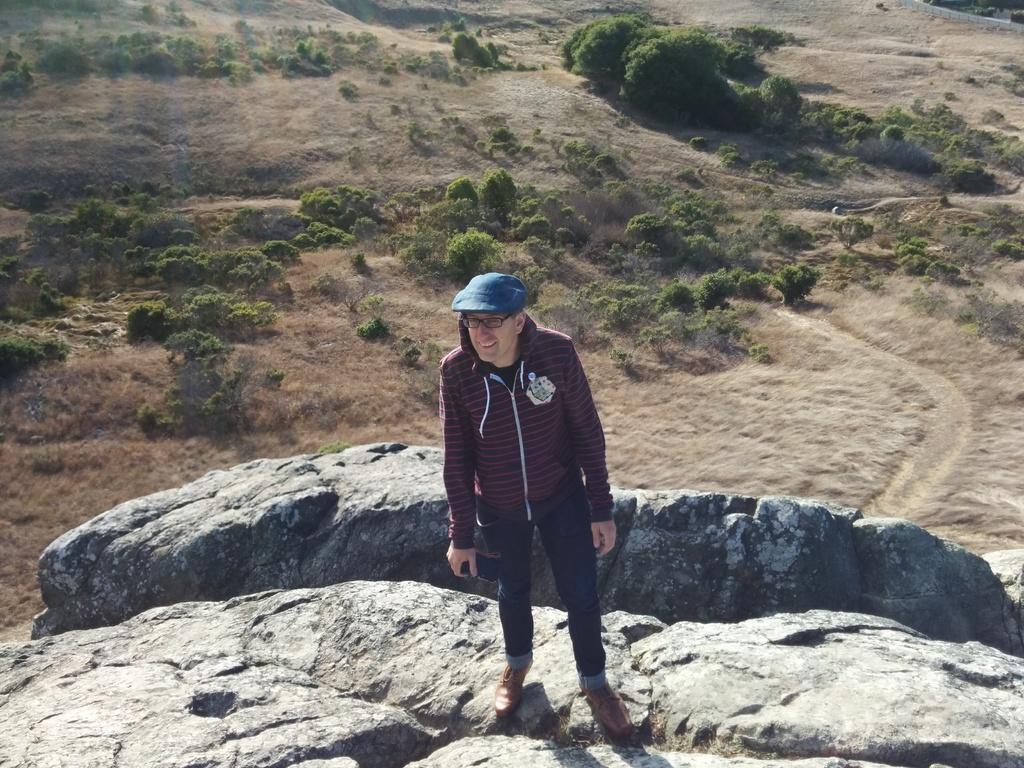In one or two sentences, can you explain what this image depicts? In this picture there is a man in the center of the image, on the rock and there are plants in the background area of the image. 